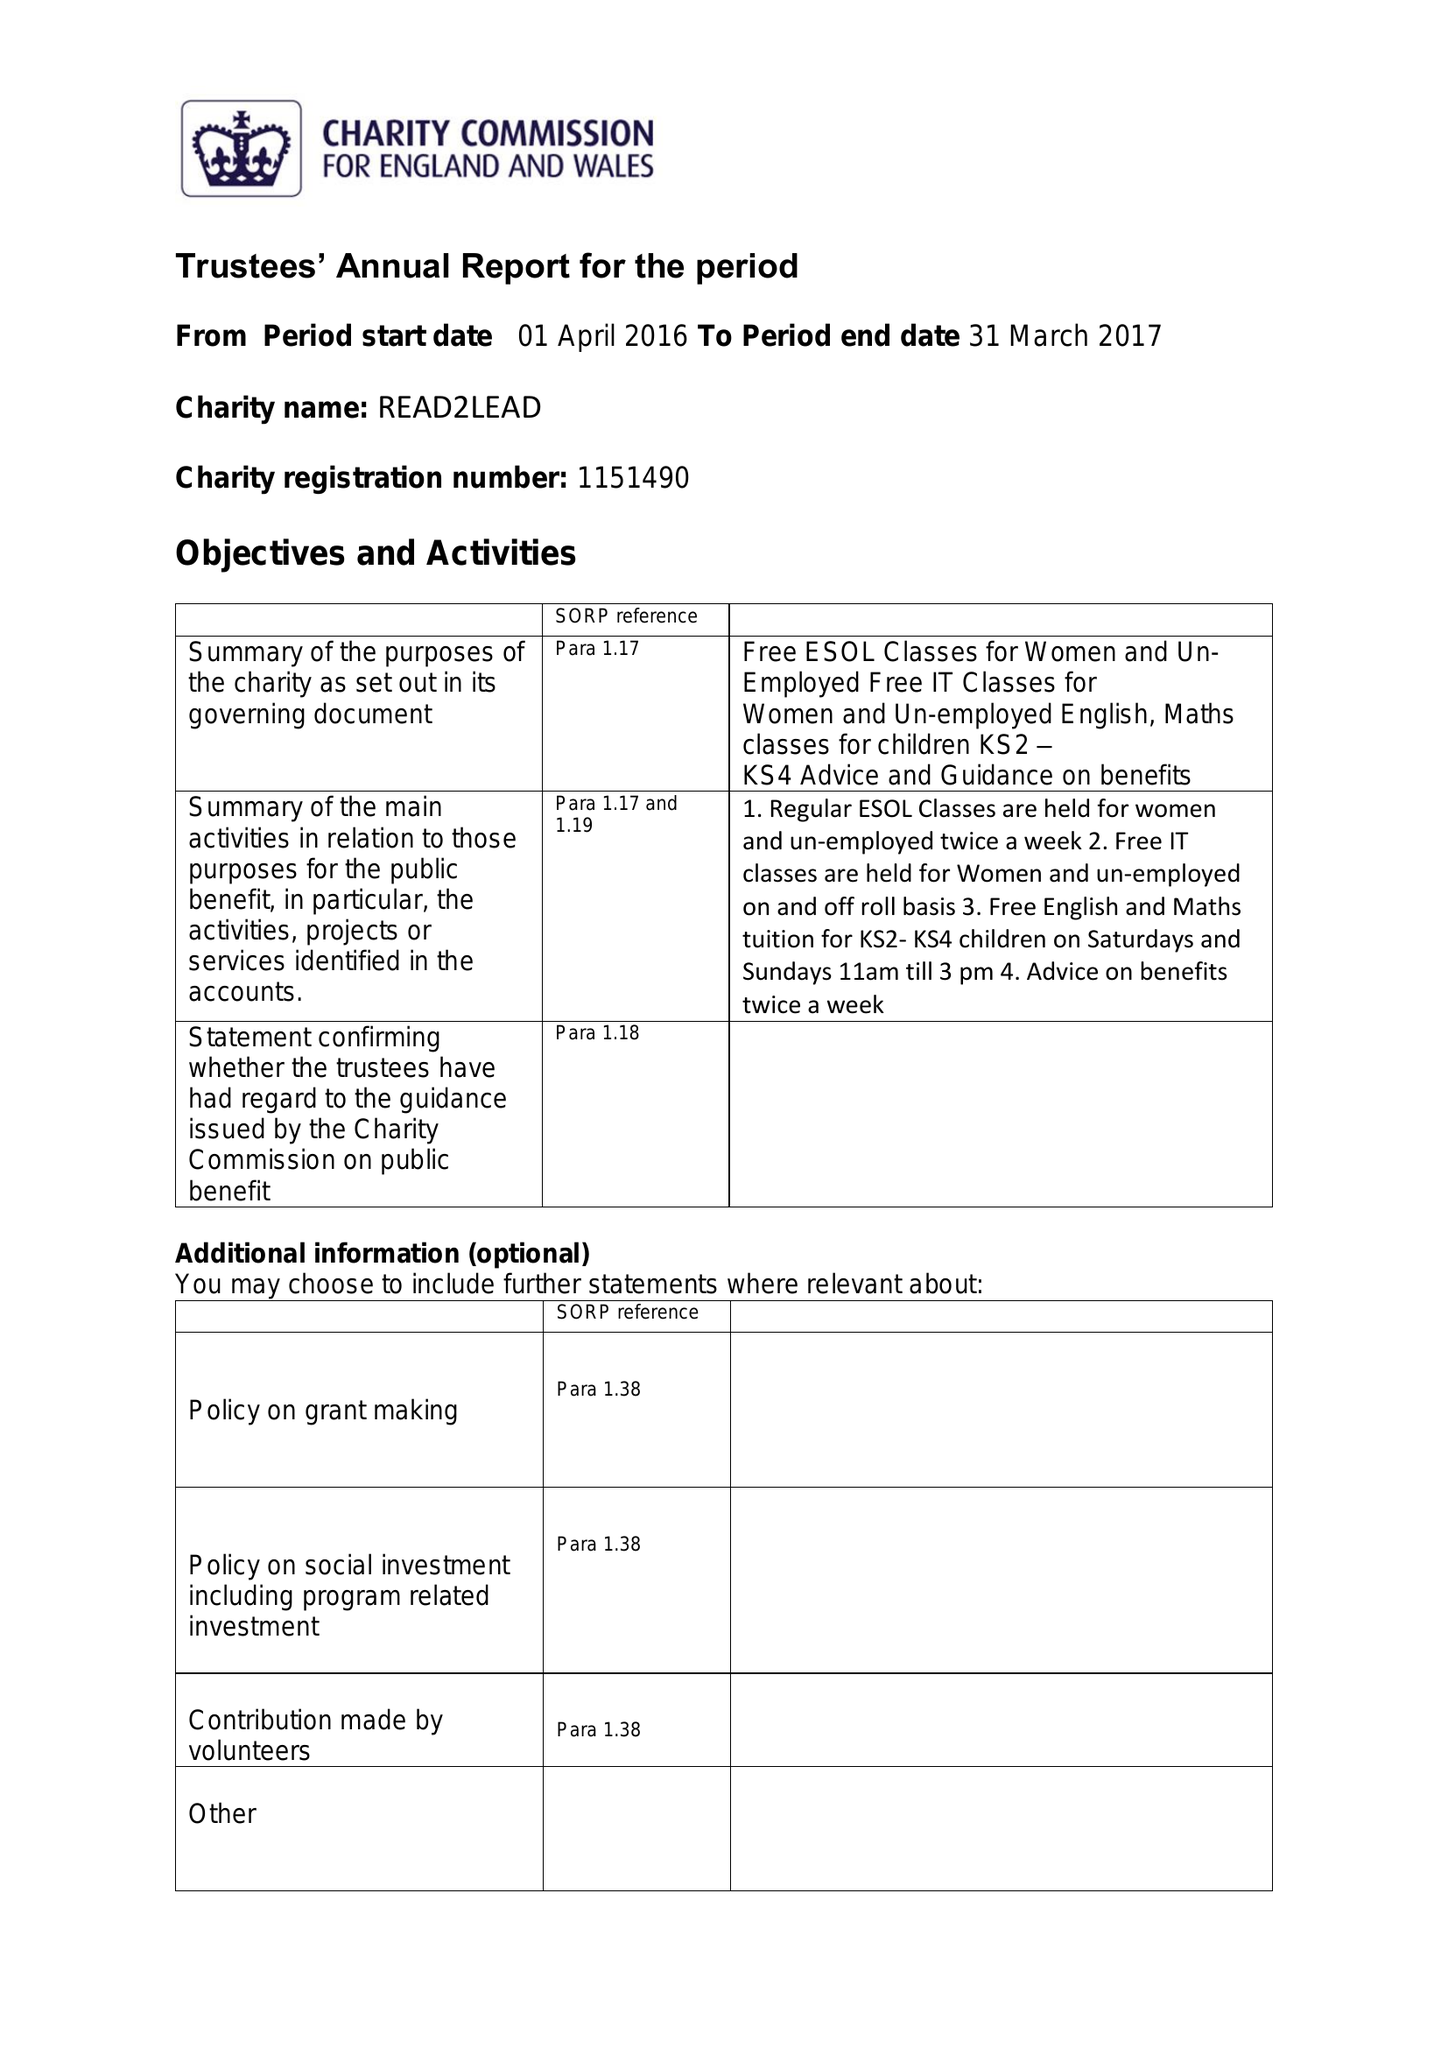What is the value for the charity_name?
Answer the question using a single word or phrase. Read2lead 